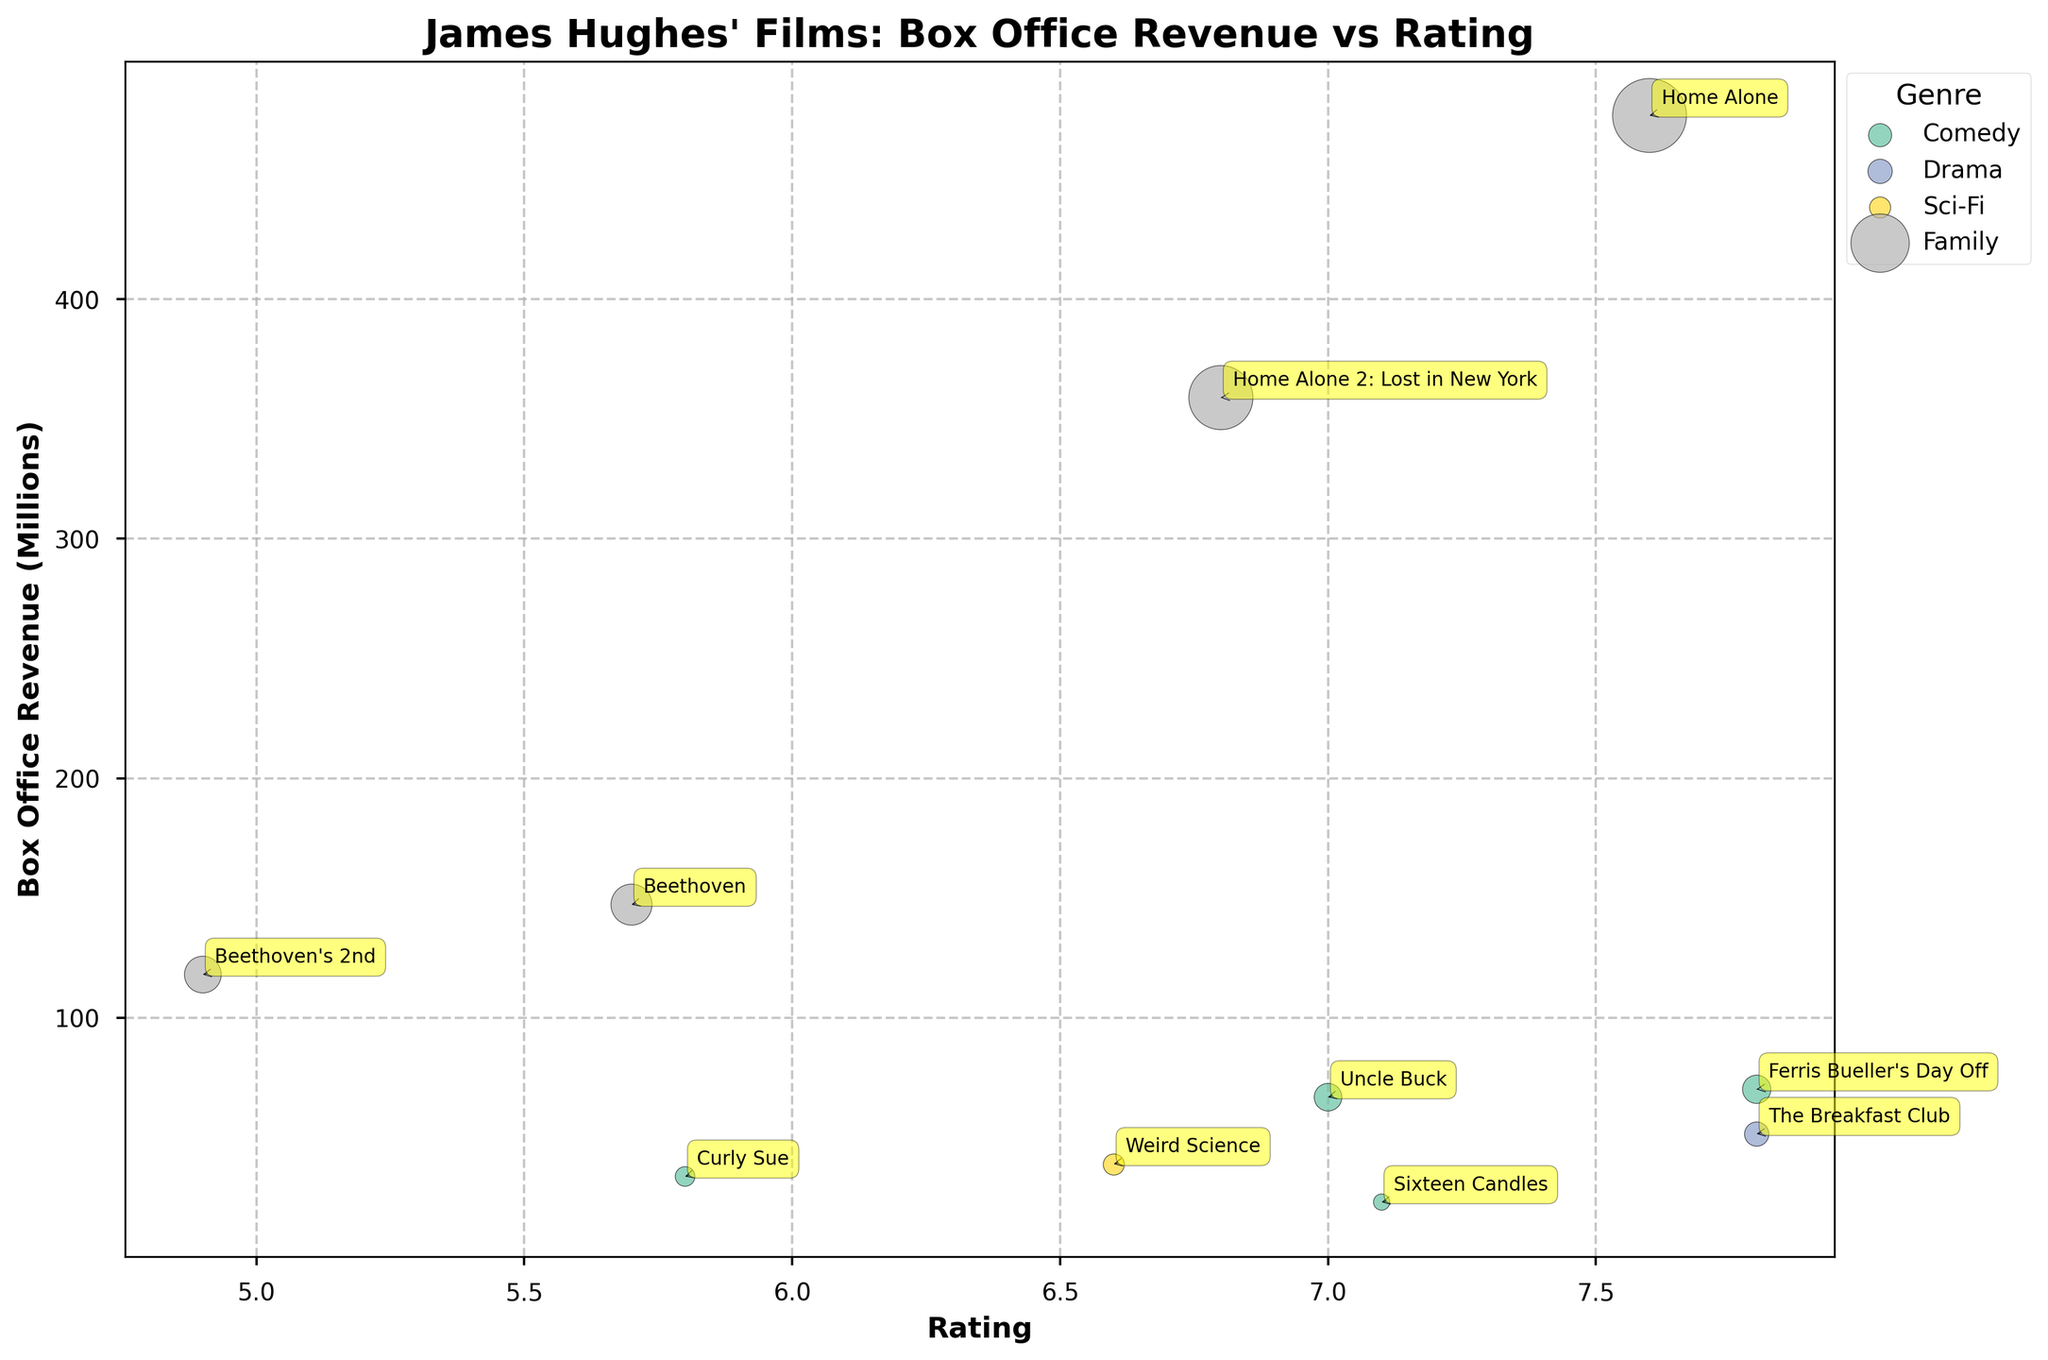What's the title of the plot? The title of the plot is usually displayed at the top of the figure. It helps understand what the data visualization is about. In this case, the title is "James Hughes' Films: Box Office Revenue vs Rating".
Answer: James Hughes' Films: Box Office Revenue vs Rating How many genres are represented in the chart? We can determine the number of genres by looking at distinct colors and/or a legend that categorizes the films. The chart shows different colors and a legend labeling genres: Comedy, Drama, Sci-Fi, and Family.
Answer: 4 Which film has the highest box office revenue? By examining the chart, we identify the bubble with the highest y-value, indicating the highest box office revenue. The highest bubble corresponds to "Home Alone" in the Family genre.
Answer: Home Alone What is the average rating of the Comedy films? To find the average rating, identify the Comedy films and their ratings: "Sixteen Candles" (7.1), "Ferris Bueller's Day Off" (7.8), "Uncle Buck" (7.0), and "Curly Sue" (5.8). Sum these ratings and divide by the number of Comedy films. (7.1 + 7.8 + 7.0 + 5.8) / 4 = 27.7 / 4.
Answer: 6.9 Between "The Breakfast Club" and "Weird Science", which film has a higher box office revenue? Locate the bubbles corresponding to these films: "The Breakfast Club" (51.5 million) and "Weird Science" (38.9 million). Compare their y-values to determine the higher revenue.
Answer: The Breakfast Club How does "Ferris Bueller's Day Off" box office compare to "Uncle Buck"? Identify the bubbles for both films: "Ferris Bueller's Day Off" (70.1 million) and "Uncle Buck" (66.8 million). Compare their y-values to see which is higher.
Answer: Ferris Bueller's Day Off What's the total box office revenue for the Family genre? Sum the box office revenue for all Family films: "Home Alone" (476.7), "Home Alone 2: Lost in New York" (358.9), "Beethoven" (147.2), and "Beethoven's 2nd" (118). 476.7 + 358.9 + 147.2 + 118 = 1100.8.
Answer: 1100.8 Which film has the lowest rating? Locate the bubble with the lowest x-value, indicating the lowest rating. The lowest rating bubble corresponds to "Beethoven's 2nd" (Rating 4.9).
Answer: Beethoven's 2nd Are there any films with a revenue higher than 300 million but a rating lower than 7? Look for bubbles with y-values greater than 300 and x-values lower than 7. "Home Alone 2: Lost in New York" qualifies with 358.9 million revenue and a rating of 6.8.
Answer: Yes, Home Alone 2: Lost in New York Which genre has the highest-rated film? Identify the film with the highest x-value (highest rating) and determine its genre. "The Breakfast Club" has the highest rating of 7.8 and belongs to the Drama genre.
Answer: Drama 